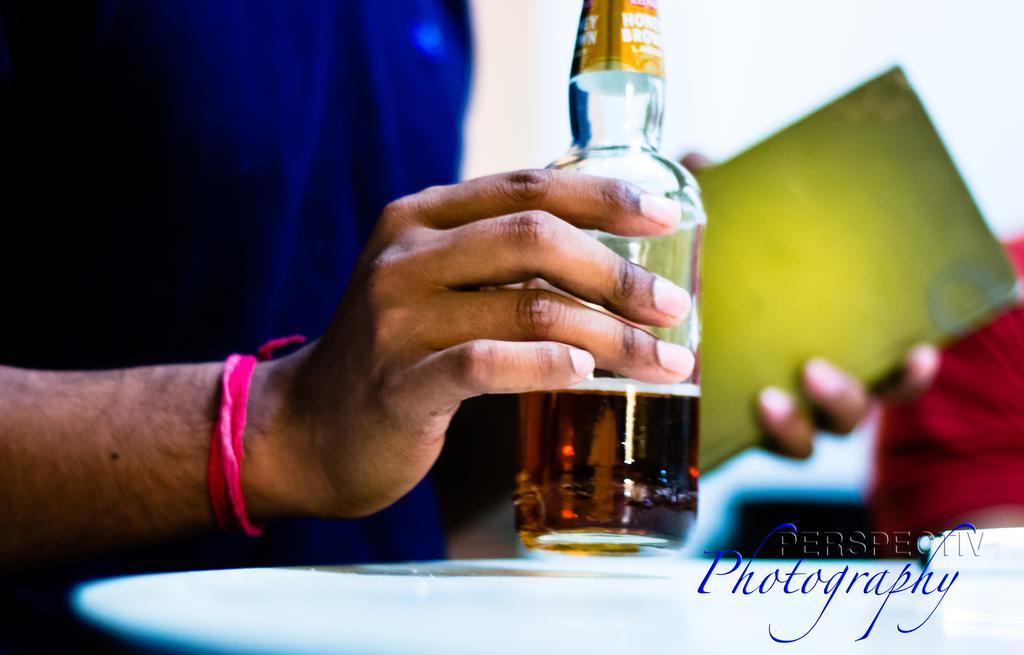<image>
Present a compact description of the photo's key features. Photograph of a person holding a bottle taken by Perspectiv Photography. 